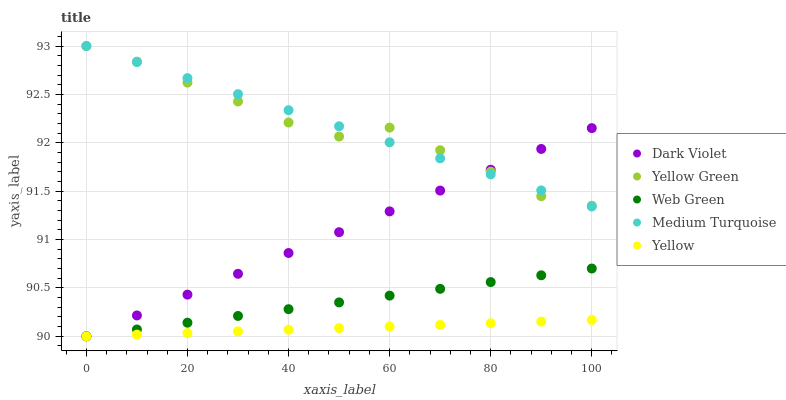Does Yellow have the minimum area under the curve?
Answer yes or no. Yes. Does Medium Turquoise have the maximum area under the curve?
Answer yes or no. Yes. Does Web Green have the minimum area under the curve?
Answer yes or no. No. Does Web Green have the maximum area under the curve?
Answer yes or no. No. Is Yellow the smoothest?
Answer yes or no. Yes. Is Yellow Green the roughest?
Answer yes or no. Yes. Is Web Green the smoothest?
Answer yes or no. No. Is Web Green the roughest?
Answer yes or no. No. Does Web Green have the lowest value?
Answer yes or no. Yes. Does Yellow Green have the lowest value?
Answer yes or no. No. Does Yellow Green have the highest value?
Answer yes or no. Yes. Does Web Green have the highest value?
Answer yes or no. No. Is Yellow less than Medium Turquoise?
Answer yes or no. Yes. Is Medium Turquoise greater than Yellow?
Answer yes or no. Yes. Does Dark Violet intersect Yellow?
Answer yes or no. Yes. Is Dark Violet less than Yellow?
Answer yes or no. No. Is Dark Violet greater than Yellow?
Answer yes or no. No. Does Yellow intersect Medium Turquoise?
Answer yes or no. No. 